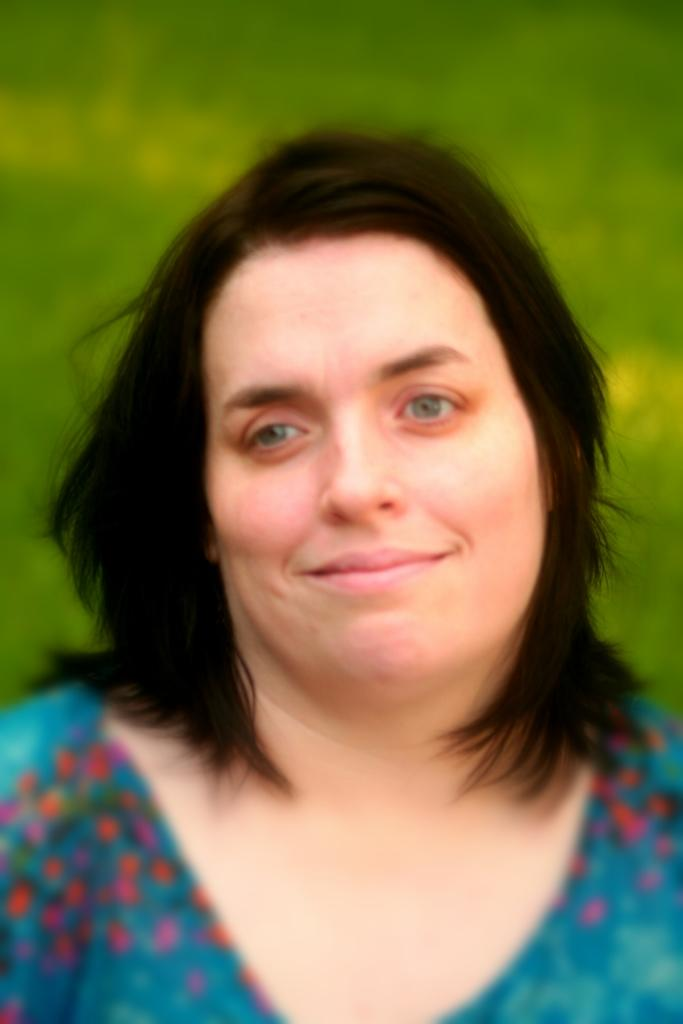Who or what is the main subject in the image? There is a person in the image. What is the person wearing? The person is wearing a green color shirt. What can be seen in the background of the image? The background of the image is green. What type of vessel is being used to hold the glue in the image? There is no vessel or glue present in the image; it features a person wearing a green shirt with a green background. 